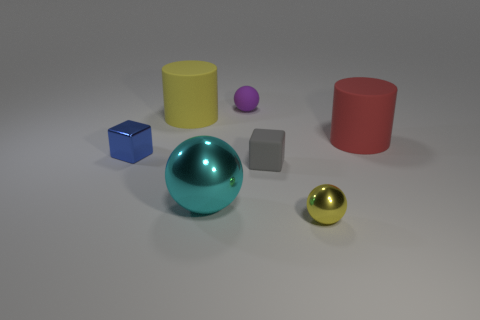The rubber thing that is the same color as the tiny shiny ball is what size?
Your answer should be very brief. Large. What number of other objects are there of the same color as the rubber ball?
Keep it short and to the point. 0. How many tiny things are in front of the yellow cylinder and to the right of the tiny blue cube?
Your answer should be very brief. 2. There is a small purple object; what shape is it?
Offer a terse response. Sphere. How many other things are there of the same material as the big cyan ball?
Make the answer very short. 2. There is a small cube to the left of the cyan shiny object to the right of the yellow cylinder that is behind the red rubber cylinder; what is its color?
Offer a terse response. Blue. What is the material of the purple thing that is the same size as the gray object?
Your response must be concise. Rubber. What number of things are small objects that are on the left side of the yellow metallic ball or large green rubber cylinders?
Offer a very short reply. 3. Is there a large rubber sphere?
Offer a terse response. No. There is a tiny ball that is in front of the blue thing; what is its material?
Give a very brief answer. Metal. 